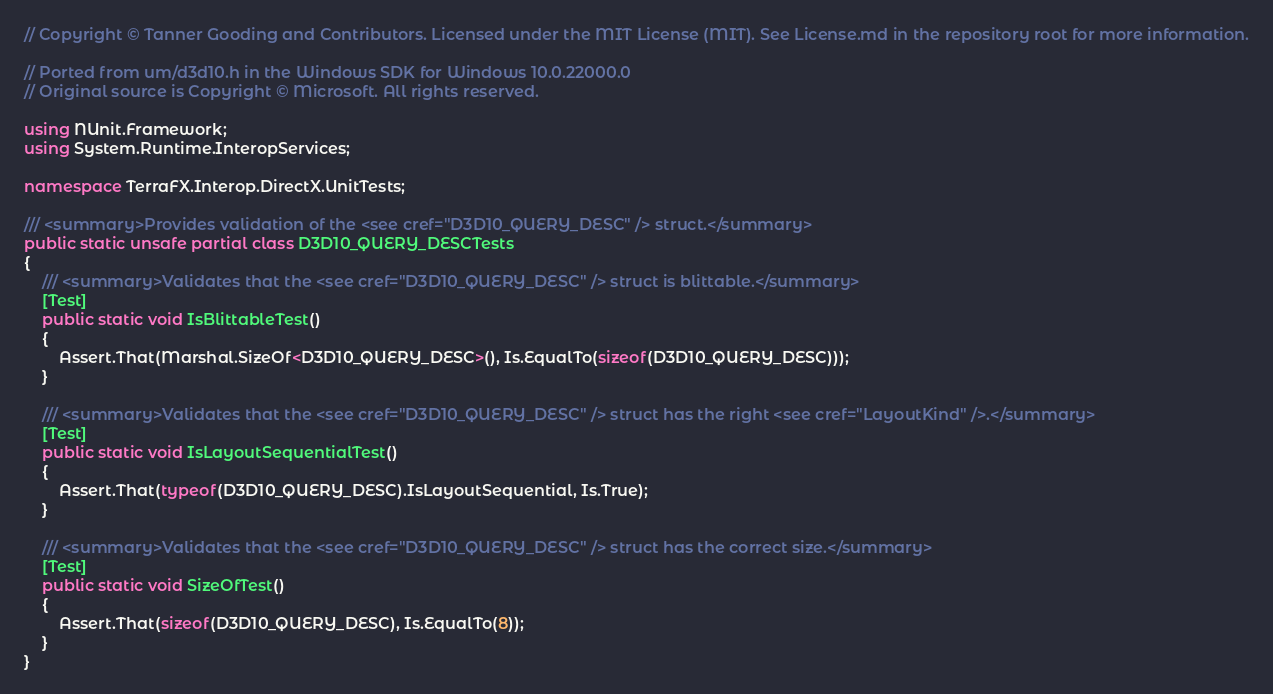<code> <loc_0><loc_0><loc_500><loc_500><_C#_>// Copyright © Tanner Gooding and Contributors. Licensed under the MIT License (MIT). See License.md in the repository root for more information.

// Ported from um/d3d10.h in the Windows SDK for Windows 10.0.22000.0
// Original source is Copyright © Microsoft. All rights reserved.

using NUnit.Framework;
using System.Runtime.InteropServices;

namespace TerraFX.Interop.DirectX.UnitTests;

/// <summary>Provides validation of the <see cref="D3D10_QUERY_DESC" /> struct.</summary>
public static unsafe partial class D3D10_QUERY_DESCTests
{
    /// <summary>Validates that the <see cref="D3D10_QUERY_DESC" /> struct is blittable.</summary>
    [Test]
    public static void IsBlittableTest()
    {
        Assert.That(Marshal.SizeOf<D3D10_QUERY_DESC>(), Is.EqualTo(sizeof(D3D10_QUERY_DESC)));
    }

    /// <summary>Validates that the <see cref="D3D10_QUERY_DESC" /> struct has the right <see cref="LayoutKind" />.</summary>
    [Test]
    public static void IsLayoutSequentialTest()
    {
        Assert.That(typeof(D3D10_QUERY_DESC).IsLayoutSequential, Is.True);
    }

    /// <summary>Validates that the <see cref="D3D10_QUERY_DESC" /> struct has the correct size.</summary>
    [Test]
    public static void SizeOfTest()
    {
        Assert.That(sizeof(D3D10_QUERY_DESC), Is.EqualTo(8));
    }
}
</code> 